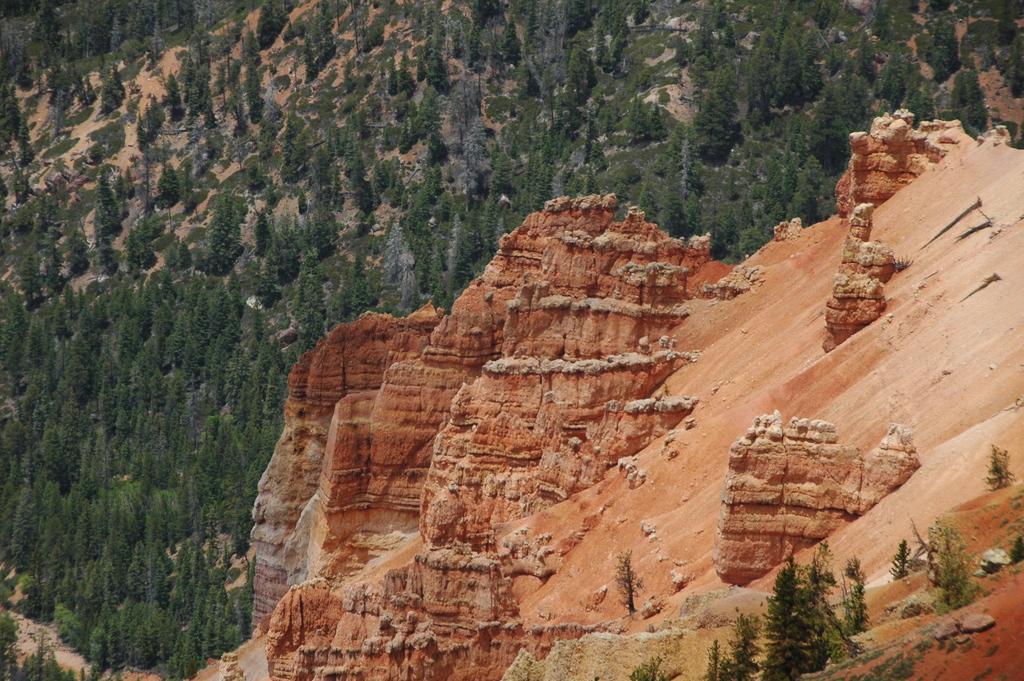Could you give a brief overview of what you see in this image? In this picture we can see a hill, in the background there are some trees, we can see stones at the right bottom. 